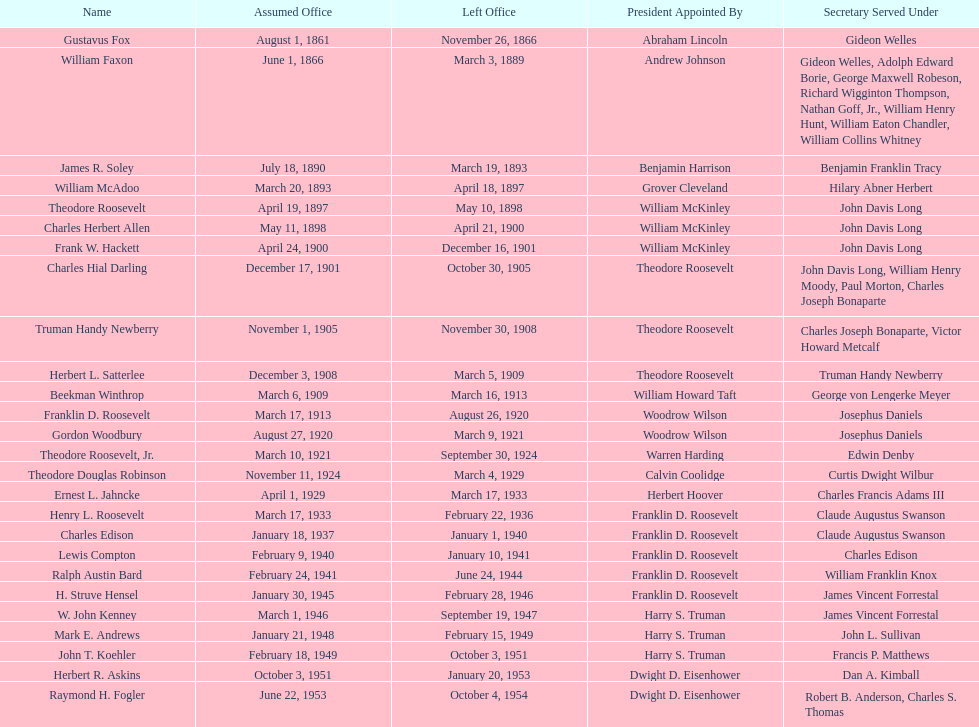What are all the names? Gustavus Fox, William Faxon, James R. Soley, William McAdoo, Theodore Roosevelt, Charles Herbert Allen, Frank W. Hackett, Charles Hial Darling, Truman Handy Newberry, Herbert L. Satterlee, Beekman Winthrop, Franklin D. Roosevelt, Gordon Woodbury, Theodore Roosevelt, Jr., Theodore Douglas Robinson, Ernest L. Jahncke, Henry L. Roosevelt, Charles Edison, Lewis Compton, Ralph Austin Bard, H. Struve Hensel, W. John Kenney, Mark E. Andrews, John T. Koehler, Herbert R. Askins, Raymond H. Fogler. When did they leave office? November 26, 1866, March 3, 1889, March 19, 1893, April 18, 1897, May 10, 1898, April 21, 1900, December 16, 1901, October 30, 1905, November 30, 1908, March 5, 1909, March 16, 1913, August 26, 1920, March 9, 1921, September 30, 1924, March 4, 1929, March 17, 1933, February 22, 1936, January 1, 1940, January 10, 1941, June 24, 1944, February 28, 1946, September 19, 1947, February 15, 1949, October 3, 1951, January 20, 1953, October 4, 1954. And when did raymond h. fogler leave? October 4, 1954. 